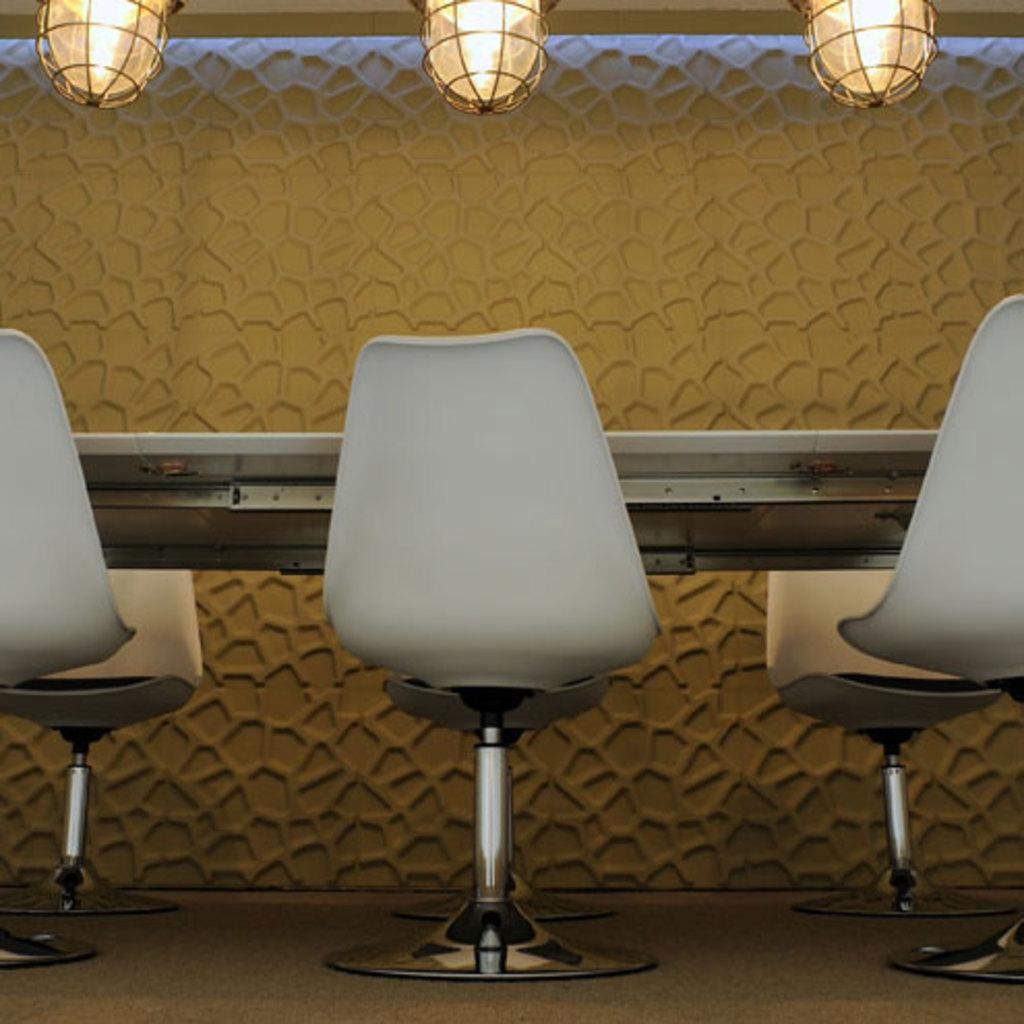What type of furniture is present in the image? There are chairs in the image. What color are the chairs? The chairs are white in color. What other piece of furniture can be seen in the background of the image? There is a table in the background of the image. What can be used for illumination in the image? There are lights visible in the image. What color is the wall in the image? The wall is cream in color. Who is the writer sitting on the chair in the image? There is no writer present in the image; it only shows chairs, a table, lights, and a cream-colored wall. 